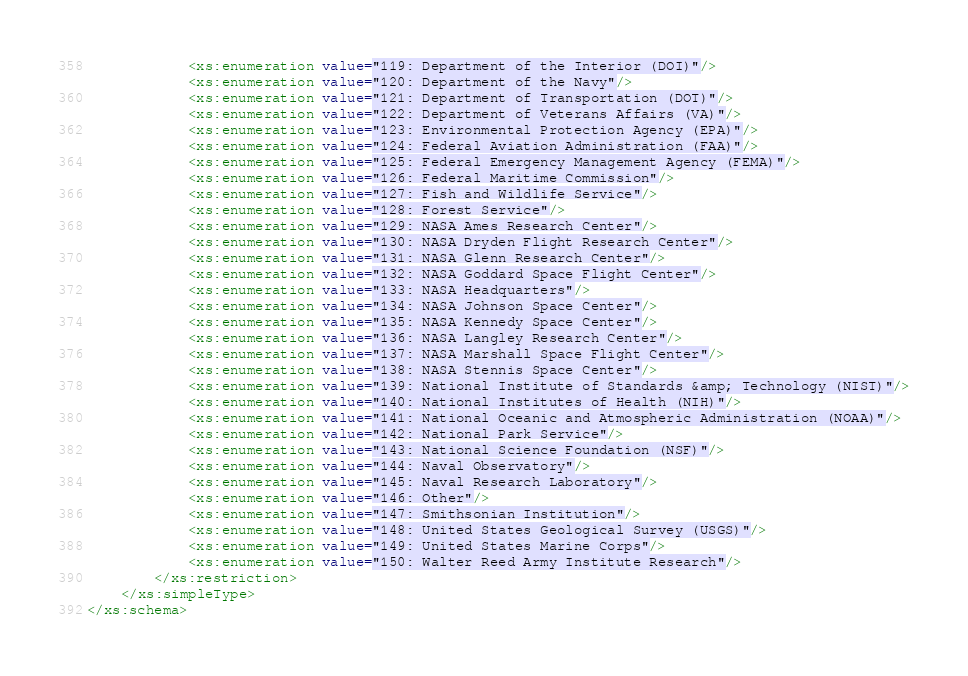<code> <loc_0><loc_0><loc_500><loc_500><_XML_>			<xs:enumeration value="119: Department of the Interior (DOI)"/>
			<xs:enumeration value="120: Department of the Navy"/>
			<xs:enumeration value="121: Department of Transportation (DOT)"/>
			<xs:enumeration value="122: Department of Veterans Affairs (VA)"/>
			<xs:enumeration value="123: Environmental Protection Agency (EPA)"/>
			<xs:enumeration value="124: Federal Aviation Administration (FAA)"/>
			<xs:enumeration value="125: Federal Emergency Management Agency (FEMA)"/>
			<xs:enumeration value="126: Federal Maritime Commission"/>
			<xs:enumeration value="127: Fish and Wildlife Service"/>
			<xs:enumeration value="128: Forest Service"/>
			<xs:enumeration value="129: NASA Ames Research Center"/>
			<xs:enumeration value="130: NASA Dryden Flight Research Center"/>
			<xs:enumeration value="131: NASA Glenn Research Center"/>
			<xs:enumeration value="132: NASA Goddard Space Flight Center"/>
			<xs:enumeration value="133: NASA Headquarters"/>
			<xs:enumeration value="134: NASA Johnson Space Center"/>
			<xs:enumeration value="135: NASA Kennedy Space Center"/>
			<xs:enumeration value="136: NASA Langley Research Center"/>
			<xs:enumeration value="137: NASA Marshall Space Flight Center"/>
			<xs:enumeration value="138: NASA Stennis Space Center"/>
			<xs:enumeration value="139: National Institute of Standards &amp; Technology (NIST)"/>
			<xs:enumeration value="140: National Institutes of Health (NIH)"/>
			<xs:enumeration value="141: National Oceanic and Atmospheric Administration (NOAA)"/>
			<xs:enumeration value="142: National Park Service"/>
			<xs:enumeration value="143: National Science Foundation (NSF)"/>
			<xs:enumeration value="144: Naval Observatory"/>
			<xs:enumeration value="145: Naval Research Laboratory"/>
			<xs:enumeration value="146: Other"/>
			<xs:enumeration value="147: Smithsonian Institution"/>
			<xs:enumeration value="148: United States Geological Survey (USGS)"/>
			<xs:enumeration value="149: United States Marine Corps"/>
			<xs:enumeration value="150: Walter Reed Army Institute Research"/>
		</xs:restriction>
	</xs:simpleType>
</xs:schema>
</code> 